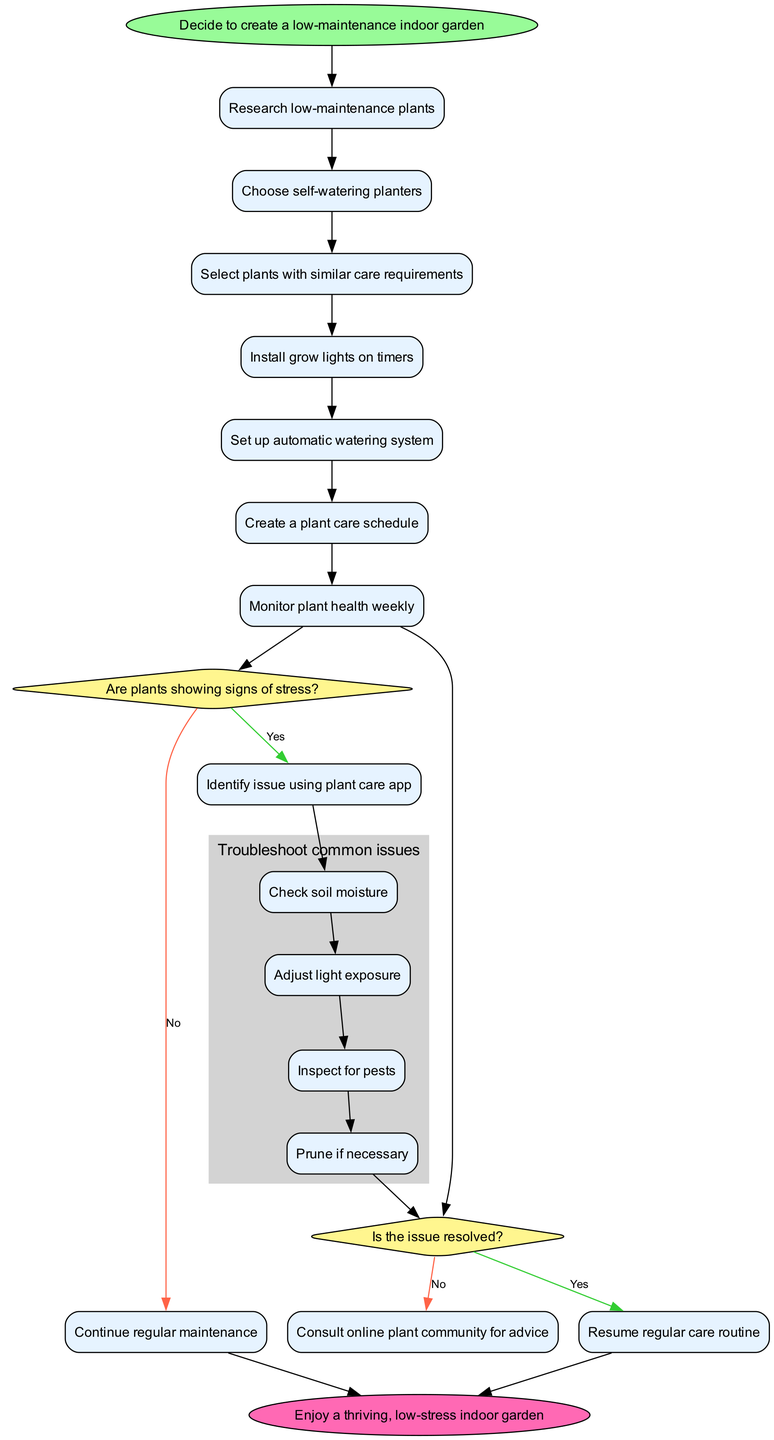What is the first activity listed in the diagram? The diagram lists the activities in sequential order, starting with "Research low-maintenance plants". Therefore, the first listed activity is simply the first node under activities.
Answer: Research low-maintenance plants How many activities are outlined in the diagram? The diagram contains a list of activities, which include seven distinct items. By counting these items, we can ascertain that there are seven activities.
Answer: Seven What is the condition that triggers the troubleshooting subprocess? The decision node checks if the plants are showing signs of stress. If the answer is yes, the flow will lead to the subprocess for troubleshooting common issues.
Answer: Are plants showing signs of stress? What is the last step in the troubleshooting subprocess? By examining the subprocess steps, the last step listed for troubleshooting common issues is "Prune if necessary". This is the culmination of the troubleshooting process.
Answer: Prune if necessary If the issue is resolved, what routine is resumed? The decision node indicates that if the issue is resolved, the flow resumes back to "Resume regular care routine". This is a specific action taken after addressing the issue.
Answer: Resume regular care routine What color represents the start node? In the diagram, the start node is visually depicted with the color light green, specifically described as "#98FB98".
Answer: Light green Which decision node leads to consulting an online plant community? The second decision node, following the first yes/no check, leads to consulting an online plant community if the issue is not resolved. It is a response to the previous assessment of whether the problem has been addressed.
Answer: Consult online plant community How many steps are there in the troubleshooting subprocess? The diagram outlines four distinct steps within the subprocess titled "Troubleshoot common issues." By counting these steps, we can determine that there are four.
Answer: Four What action follows after the "Identify issue using plant care app" decision? Following the decision to identify an issue using a plant care app, the diagram indicates that if the issue persists, the next action is to proceed to consult an online plant community.
Answer: Consult online plant community 